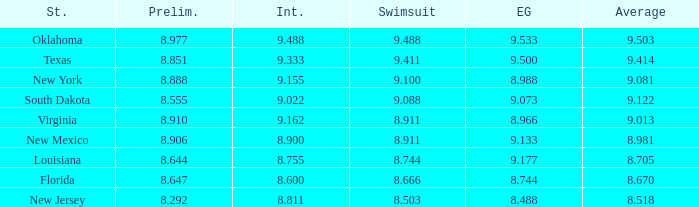 what's the swimsuit where average is 8.670 8.666. 